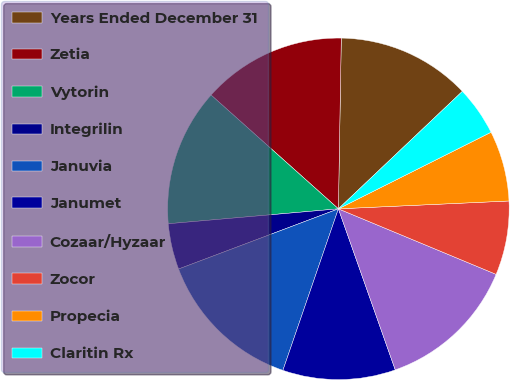Convert chart to OTSL. <chart><loc_0><loc_0><loc_500><loc_500><pie_chart><fcel>Years Ended December 31<fcel>Zetia<fcel>Vytorin<fcel>Integrilin<fcel>Januvia<fcel>Janumet<fcel>Cozaar/Hyzaar<fcel>Zocor<fcel>Propecia<fcel>Claritin Rx<nl><fcel>12.66%<fcel>13.66%<fcel>13.0%<fcel>4.34%<fcel>14.0%<fcel>10.67%<fcel>13.33%<fcel>7.0%<fcel>6.67%<fcel>4.67%<nl></chart> 